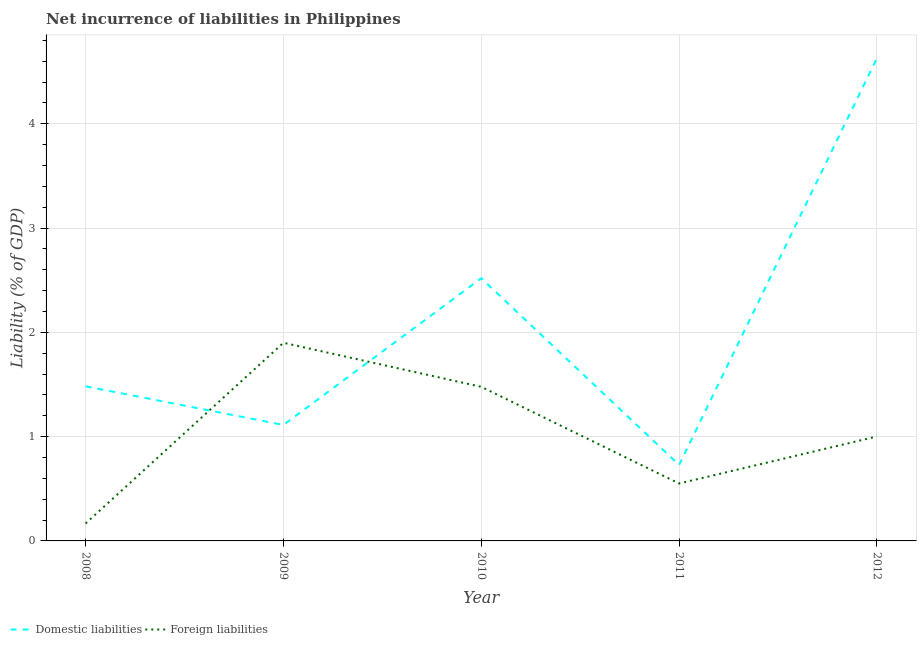How many different coloured lines are there?
Give a very brief answer. 2. Does the line corresponding to incurrence of domestic liabilities intersect with the line corresponding to incurrence of foreign liabilities?
Provide a short and direct response. Yes. Is the number of lines equal to the number of legend labels?
Offer a terse response. Yes. What is the incurrence of domestic liabilities in 2011?
Make the answer very short. 0.73. Across all years, what is the maximum incurrence of domestic liabilities?
Keep it short and to the point. 4.63. Across all years, what is the minimum incurrence of foreign liabilities?
Ensure brevity in your answer.  0.17. In which year was the incurrence of domestic liabilities maximum?
Your response must be concise. 2012. In which year was the incurrence of foreign liabilities minimum?
Give a very brief answer. 2008. What is the total incurrence of domestic liabilities in the graph?
Offer a very short reply. 10.47. What is the difference between the incurrence of domestic liabilities in 2008 and that in 2012?
Your response must be concise. -3.15. What is the difference between the incurrence of domestic liabilities in 2011 and the incurrence of foreign liabilities in 2008?
Keep it short and to the point. 0.56. What is the average incurrence of foreign liabilities per year?
Keep it short and to the point. 1.02. In the year 2011, what is the difference between the incurrence of domestic liabilities and incurrence of foreign liabilities?
Offer a very short reply. 0.18. In how many years, is the incurrence of foreign liabilities greater than 3 %?
Make the answer very short. 0. What is the ratio of the incurrence of foreign liabilities in 2009 to that in 2011?
Keep it short and to the point. 3.45. What is the difference between the highest and the second highest incurrence of foreign liabilities?
Offer a terse response. 0.42. What is the difference between the highest and the lowest incurrence of domestic liabilities?
Your answer should be very brief. 3.9. Is the sum of the incurrence of foreign liabilities in 2010 and 2012 greater than the maximum incurrence of domestic liabilities across all years?
Provide a succinct answer. No. Are the values on the major ticks of Y-axis written in scientific E-notation?
Provide a succinct answer. No. Does the graph contain grids?
Your answer should be very brief. Yes. Where does the legend appear in the graph?
Provide a short and direct response. Bottom left. What is the title of the graph?
Provide a short and direct response. Net incurrence of liabilities in Philippines. What is the label or title of the X-axis?
Your answer should be very brief. Year. What is the label or title of the Y-axis?
Give a very brief answer. Liability (% of GDP). What is the Liability (% of GDP) of Domestic liabilities in 2008?
Offer a terse response. 1.48. What is the Liability (% of GDP) of Foreign liabilities in 2008?
Make the answer very short. 0.17. What is the Liability (% of GDP) in Domestic liabilities in 2009?
Offer a very short reply. 1.11. What is the Liability (% of GDP) in Foreign liabilities in 2009?
Make the answer very short. 1.9. What is the Liability (% of GDP) of Domestic liabilities in 2010?
Your answer should be very brief. 2.52. What is the Liability (% of GDP) of Foreign liabilities in 2010?
Your answer should be very brief. 1.48. What is the Liability (% of GDP) of Domestic liabilities in 2011?
Make the answer very short. 0.73. What is the Liability (% of GDP) in Foreign liabilities in 2011?
Keep it short and to the point. 0.55. What is the Liability (% of GDP) of Domestic liabilities in 2012?
Offer a terse response. 4.63. What is the Liability (% of GDP) in Foreign liabilities in 2012?
Give a very brief answer. 1. Across all years, what is the maximum Liability (% of GDP) of Domestic liabilities?
Your response must be concise. 4.63. Across all years, what is the maximum Liability (% of GDP) of Foreign liabilities?
Ensure brevity in your answer.  1.9. Across all years, what is the minimum Liability (% of GDP) of Domestic liabilities?
Offer a very short reply. 0.73. Across all years, what is the minimum Liability (% of GDP) of Foreign liabilities?
Ensure brevity in your answer.  0.17. What is the total Liability (% of GDP) of Domestic liabilities in the graph?
Make the answer very short. 10.47. What is the total Liability (% of GDP) of Foreign liabilities in the graph?
Your answer should be compact. 5.1. What is the difference between the Liability (% of GDP) of Domestic liabilities in 2008 and that in 2009?
Offer a terse response. 0.37. What is the difference between the Liability (% of GDP) in Foreign liabilities in 2008 and that in 2009?
Your response must be concise. -1.73. What is the difference between the Liability (% of GDP) of Domestic liabilities in 2008 and that in 2010?
Your answer should be very brief. -1.04. What is the difference between the Liability (% of GDP) of Foreign liabilities in 2008 and that in 2010?
Give a very brief answer. -1.31. What is the difference between the Liability (% of GDP) of Domestic liabilities in 2008 and that in 2011?
Keep it short and to the point. 0.75. What is the difference between the Liability (% of GDP) of Foreign liabilities in 2008 and that in 2011?
Your response must be concise. -0.38. What is the difference between the Liability (% of GDP) of Domestic liabilities in 2008 and that in 2012?
Give a very brief answer. -3.15. What is the difference between the Liability (% of GDP) in Foreign liabilities in 2008 and that in 2012?
Offer a terse response. -0.83. What is the difference between the Liability (% of GDP) of Domestic liabilities in 2009 and that in 2010?
Give a very brief answer. -1.41. What is the difference between the Liability (% of GDP) of Foreign liabilities in 2009 and that in 2010?
Your response must be concise. 0.42. What is the difference between the Liability (% of GDP) in Domestic liabilities in 2009 and that in 2011?
Ensure brevity in your answer.  0.38. What is the difference between the Liability (% of GDP) in Foreign liabilities in 2009 and that in 2011?
Ensure brevity in your answer.  1.35. What is the difference between the Liability (% of GDP) of Domestic liabilities in 2009 and that in 2012?
Keep it short and to the point. -3.52. What is the difference between the Liability (% of GDP) of Foreign liabilities in 2009 and that in 2012?
Your answer should be compact. 0.9. What is the difference between the Liability (% of GDP) in Domestic liabilities in 2010 and that in 2011?
Keep it short and to the point. 1.79. What is the difference between the Liability (% of GDP) of Foreign liabilities in 2010 and that in 2011?
Give a very brief answer. 0.93. What is the difference between the Liability (% of GDP) of Domestic liabilities in 2010 and that in 2012?
Your answer should be compact. -2.11. What is the difference between the Liability (% of GDP) in Foreign liabilities in 2010 and that in 2012?
Provide a short and direct response. 0.48. What is the difference between the Liability (% of GDP) of Domestic liabilities in 2011 and that in 2012?
Give a very brief answer. -3.9. What is the difference between the Liability (% of GDP) of Foreign liabilities in 2011 and that in 2012?
Keep it short and to the point. -0.45. What is the difference between the Liability (% of GDP) in Domestic liabilities in 2008 and the Liability (% of GDP) in Foreign liabilities in 2009?
Provide a short and direct response. -0.42. What is the difference between the Liability (% of GDP) of Domestic liabilities in 2008 and the Liability (% of GDP) of Foreign liabilities in 2010?
Your answer should be very brief. 0. What is the difference between the Liability (% of GDP) of Domestic liabilities in 2008 and the Liability (% of GDP) of Foreign liabilities in 2011?
Ensure brevity in your answer.  0.93. What is the difference between the Liability (% of GDP) of Domestic liabilities in 2008 and the Liability (% of GDP) of Foreign liabilities in 2012?
Give a very brief answer. 0.48. What is the difference between the Liability (% of GDP) of Domestic liabilities in 2009 and the Liability (% of GDP) of Foreign liabilities in 2010?
Keep it short and to the point. -0.37. What is the difference between the Liability (% of GDP) in Domestic liabilities in 2009 and the Liability (% of GDP) in Foreign liabilities in 2011?
Keep it short and to the point. 0.56. What is the difference between the Liability (% of GDP) of Domestic liabilities in 2009 and the Liability (% of GDP) of Foreign liabilities in 2012?
Your answer should be compact. 0.11. What is the difference between the Liability (% of GDP) of Domestic liabilities in 2010 and the Liability (% of GDP) of Foreign liabilities in 2011?
Provide a short and direct response. 1.97. What is the difference between the Liability (% of GDP) of Domestic liabilities in 2010 and the Liability (% of GDP) of Foreign liabilities in 2012?
Provide a succinct answer. 1.52. What is the difference between the Liability (% of GDP) of Domestic liabilities in 2011 and the Liability (% of GDP) of Foreign liabilities in 2012?
Your answer should be compact. -0.27. What is the average Liability (% of GDP) in Domestic liabilities per year?
Offer a very short reply. 2.09. What is the average Liability (% of GDP) in Foreign liabilities per year?
Your response must be concise. 1.02. In the year 2008, what is the difference between the Liability (% of GDP) in Domestic liabilities and Liability (% of GDP) in Foreign liabilities?
Make the answer very short. 1.32. In the year 2009, what is the difference between the Liability (% of GDP) of Domestic liabilities and Liability (% of GDP) of Foreign liabilities?
Make the answer very short. -0.79. In the year 2010, what is the difference between the Liability (% of GDP) of Domestic liabilities and Liability (% of GDP) of Foreign liabilities?
Give a very brief answer. 1.04. In the year 2011, what is the difference between the Liability (% of GDP) in Domestic liabilities and Liability (% of GDP) in Foreign liabilities?
Give a very brief answer. 0.18. In the year 2012, what is the difference between the Liability (% of GDP) of Domestic liabilities and Liability (% of GDP) of Foreign liabilities?
Offer a terse response. 3.63. What is the ratio of the Liability (% of GDP) of Domestic liabilities in 2008 to that in 2009?
Give a very brief answer. 1.33. What is the ratio of the Liability (% of GDP) in Foreign liabilities in 2008 to that in 2009?
Give a very brief answer. 0.09. What is the ratio of the Liability (% of GDP) of Domestic liabilities in 2008 to that in 2010?
Give a very brief answer. 0.59. What is the ratio of the Liability (% of GDP) in Foreign liabilities in 2008 to that in 2010?
Keep it short and to the point. 0.11. What is the ratio of the Liability (% of GDP) of Domestic liabilities in 2008 to that in 2011?
Give a very brief answer. 2.04. What is the ratio of the Liability (% of GDP) in Foreign liabilities in 2008 to that in 2011?
Offer a terse response. 0.3. What is the ratio of the Liability (% of GDP) of Domestic liabilities in 2008 to that in 2012?
Your response must be concise. 0.32. What is the ratio of the Liability (% of GDP) in Foreign liabilities in 2008 to that in 2012?
Keep it short and to the point. 0.17. What is the ratio of the Liability (% of GDP) of Domestic liabilities in 2009 to that in 2010?
Your answer should be compact. 0.44. What is the ratio of the Liability (% of GDP) in Foreign liabilities in 2009 to that in 2010?
Your answer should be compact. 1.29. What is the ratio of the Liability (% of GDP) in Domestic liabilities in 2009 to that in 2011?
Keep it short and to the point. 1.53. What is the ratio of the Liability (% of GDP) in Foreign liabilities in 2009 to that in 2011?
Provide a short and direct response. 3.45. What is the ratio of the Liability (% of GDP) in Domestic liabilities in 2009 to that in 2012?
Your answer should be compact. 0.24. What is the ratio of the Liability (% of GDP) of Foreign liabilities in 2009 to that in 2012?
Offer a very short reply. 1.9. What is the ratio of the Liability (% of GDP) of Domestic liabilities in 2010 to that in 2011?
Offer a terse response. 3.46. What is the ratio of the Liability (% of GDP) of Foreign liabilities in 2010 to that in 2011?
Offer a very short reply. 2.68. What is the ratio of the Liability (% of GDP) in Domestic liabilities in 2010 to that in 2012?
Provide a short and direct response. 0.54. What is the ratio of the Liability (% of GDP) of Foreign liabilities in 2010 to that in 2012?
Offer a terse response. 1.48. What is the ratio of the Liability (% of GDP) of Domestic liabilities in 2011 to that in 2012?
Your answer should be compact. 0.16. What is the ratio of the Liability (% of GDP) in Foreign liabilities in 2011 to that in 2012?
Ensure brevity in your answer.  0.55. What is the difference between the highest and the second highest Liability (% of GDP) of Domestic liabilities?
Ensure brevity in your answer.  2.11. What is the difference between the highest and the second highest Liability (% of GDP) of Foreign liabilities?
Provide a short and direct response. 0.42. What is the difference between the highest and the lowest Liability (% of GDP) in Domestic liabilities?
Your answer should be very brief. 3.9. What is the difference between the highest and the lowest Liability (% of GDP) in Foreign liabilities?
Keep it short and to the point. 1.73. 